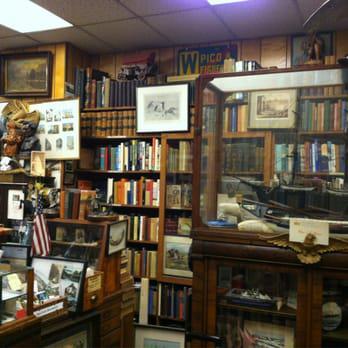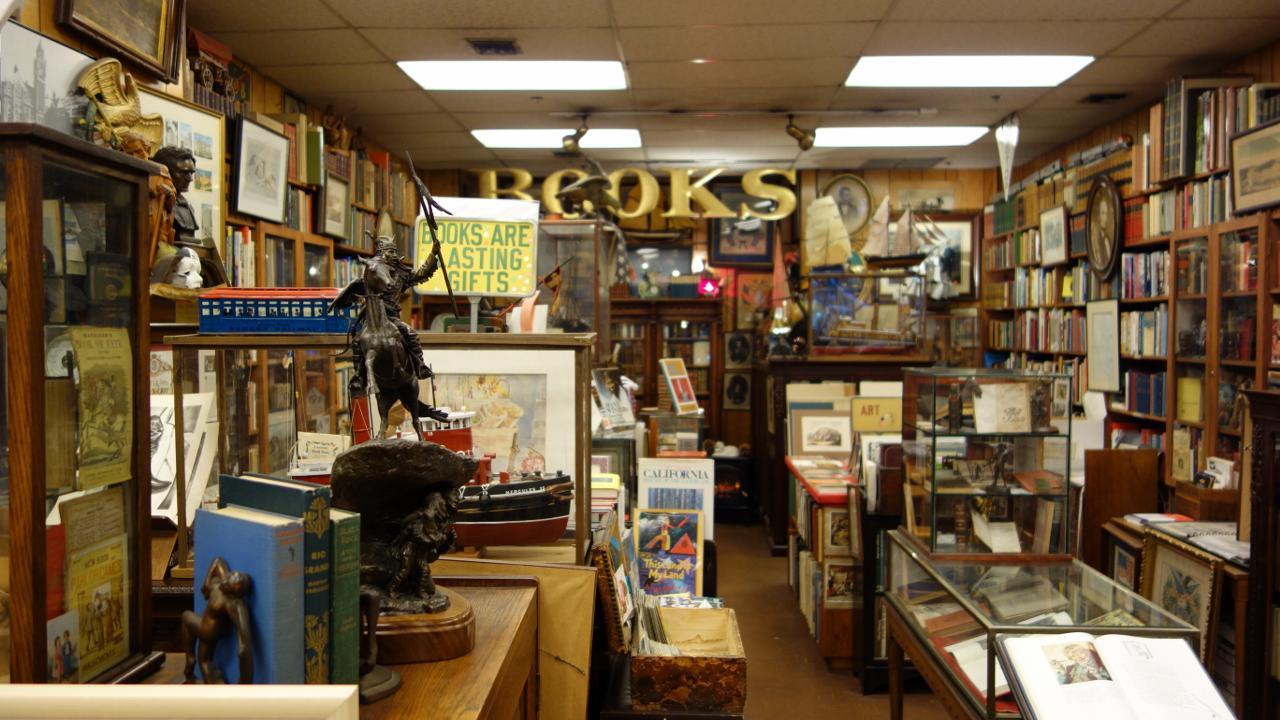The first image is the image on the left, the second image is the image on the right. Examine the images to the left and right. Is the description "A man is near some books." accurate? Answer yes or no. No. 